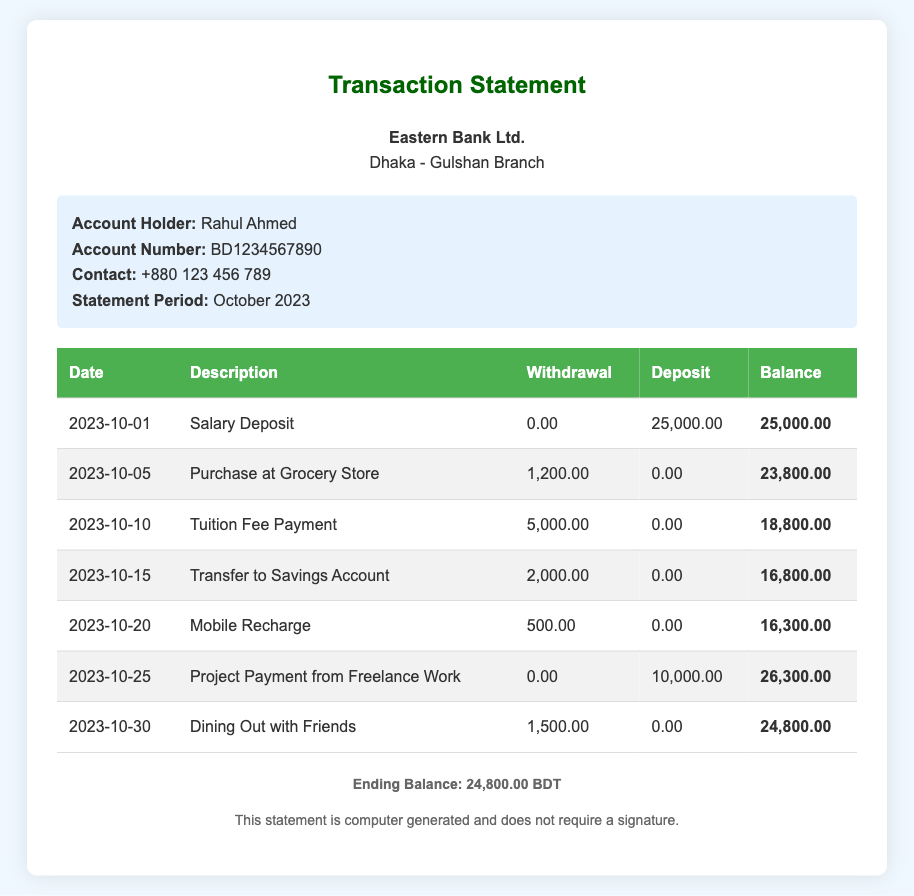What is the date of the first transaction? The first transaction listed in the statement is on 2023-10-01.
Answer: 2023-10-01 What was the amount deposited on October 1st? The transaction for salary deposit indicates a deposit of 25,000.00 BDT.
Answer: 25,000.00 What is the total amount withdrawn on October 10th? The tuition fee payment on October 10th shows a withdrawal of 5,000.00 BDT.
Answer: 5,000.00 What was the balance after the mobile recharge? The balance after the mobile recharge on October 20th was 16,300.00 BDT.
Answer: 16,300.00 What is the ending balance stated in the document? The ending balance at the end of the statement is clearly indicated as 24,800.00 BDT.
Answer: 24,800.00 How much was earned from freelance work? The project payment from freelance work shows an income of 10,000.00 BDT.
Answer: 10,000.00 What was the description of the transaction on October 5th? The transaction on October 5th is described as a purchase at the grocery store.
Answer: Purchase at Grocery Store Which transaction had the highest withdrawal amount? The highest withdrawal amount is from the tuition fee payment at 5,000.00 BDT.
Answer: 5,000.00 How many transactions are listed in the document? There are a total of 7 transactions listed in the statement.
Answer: 7 